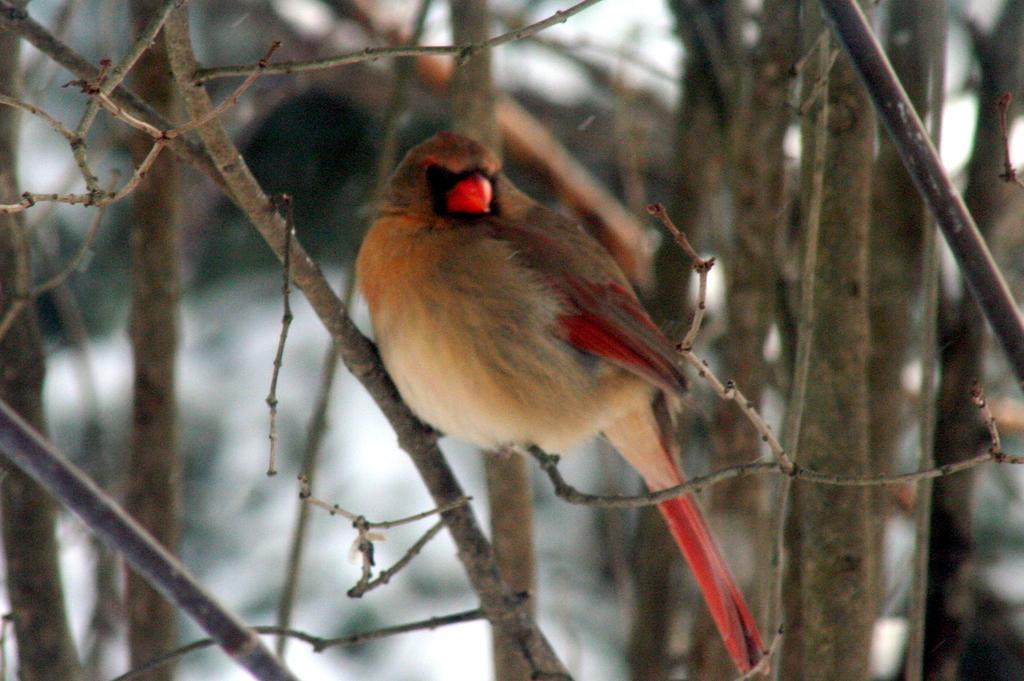What type of animal can be seen in the image? There is a bird in the image. Where is the bird located in the image? The bird is sitting on a stem. What can be seen in the background of the image? There are trees in the background of the image. How would you describe the background of the image? The background is blurred. What type of cable can be seen running through the bird's nest in the image? There is no cable present in the image, nor is there a bird's nest. 